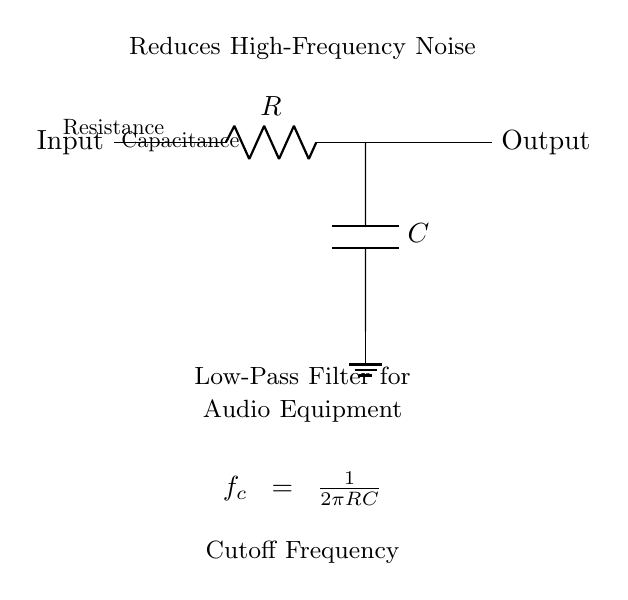What type of circuit is depicted? The circuit is a low-pass filter, which is used to allow low-frequency signals to pass while attenuating high-frequency signals.
Answer: Low-pass filter What components are included in the circuit? The circuit includes a resistor and a capacitor. The resistor is labeled as R, and the capacitor is labeled as C.
Answer: Resistor and capacitor What is the purpose of the low-pass filter in audio equipment? The low-pass filter serves to reduce high-frequency noise that may interfere with audio signals, ensuring clearer sound reproduction from the equipment.
Answer: Reduces high-frequency noise What is the cutoff frequency formula presented in the circuit? The cutoff frequency formula is given by f_c = 1/(2πRC). This formula defines the frequency at which the output signal is reduced to a specific level, indicating the filter's effectiveness.
Answer: f_c = 1/(2πRC) What does the ground symbol indicate in the circuit? The ground symbol indicates a reference point for the circuit, providing a common return path for electric current and ensuring stable operation of the components.
Answer: Ground reference At which point does the output signal leave the circuit? The output signal leaves the circuit from the right side of the circuit diagram, after the capacitor, where it is labeled simply as "Output".
Answer: Output 